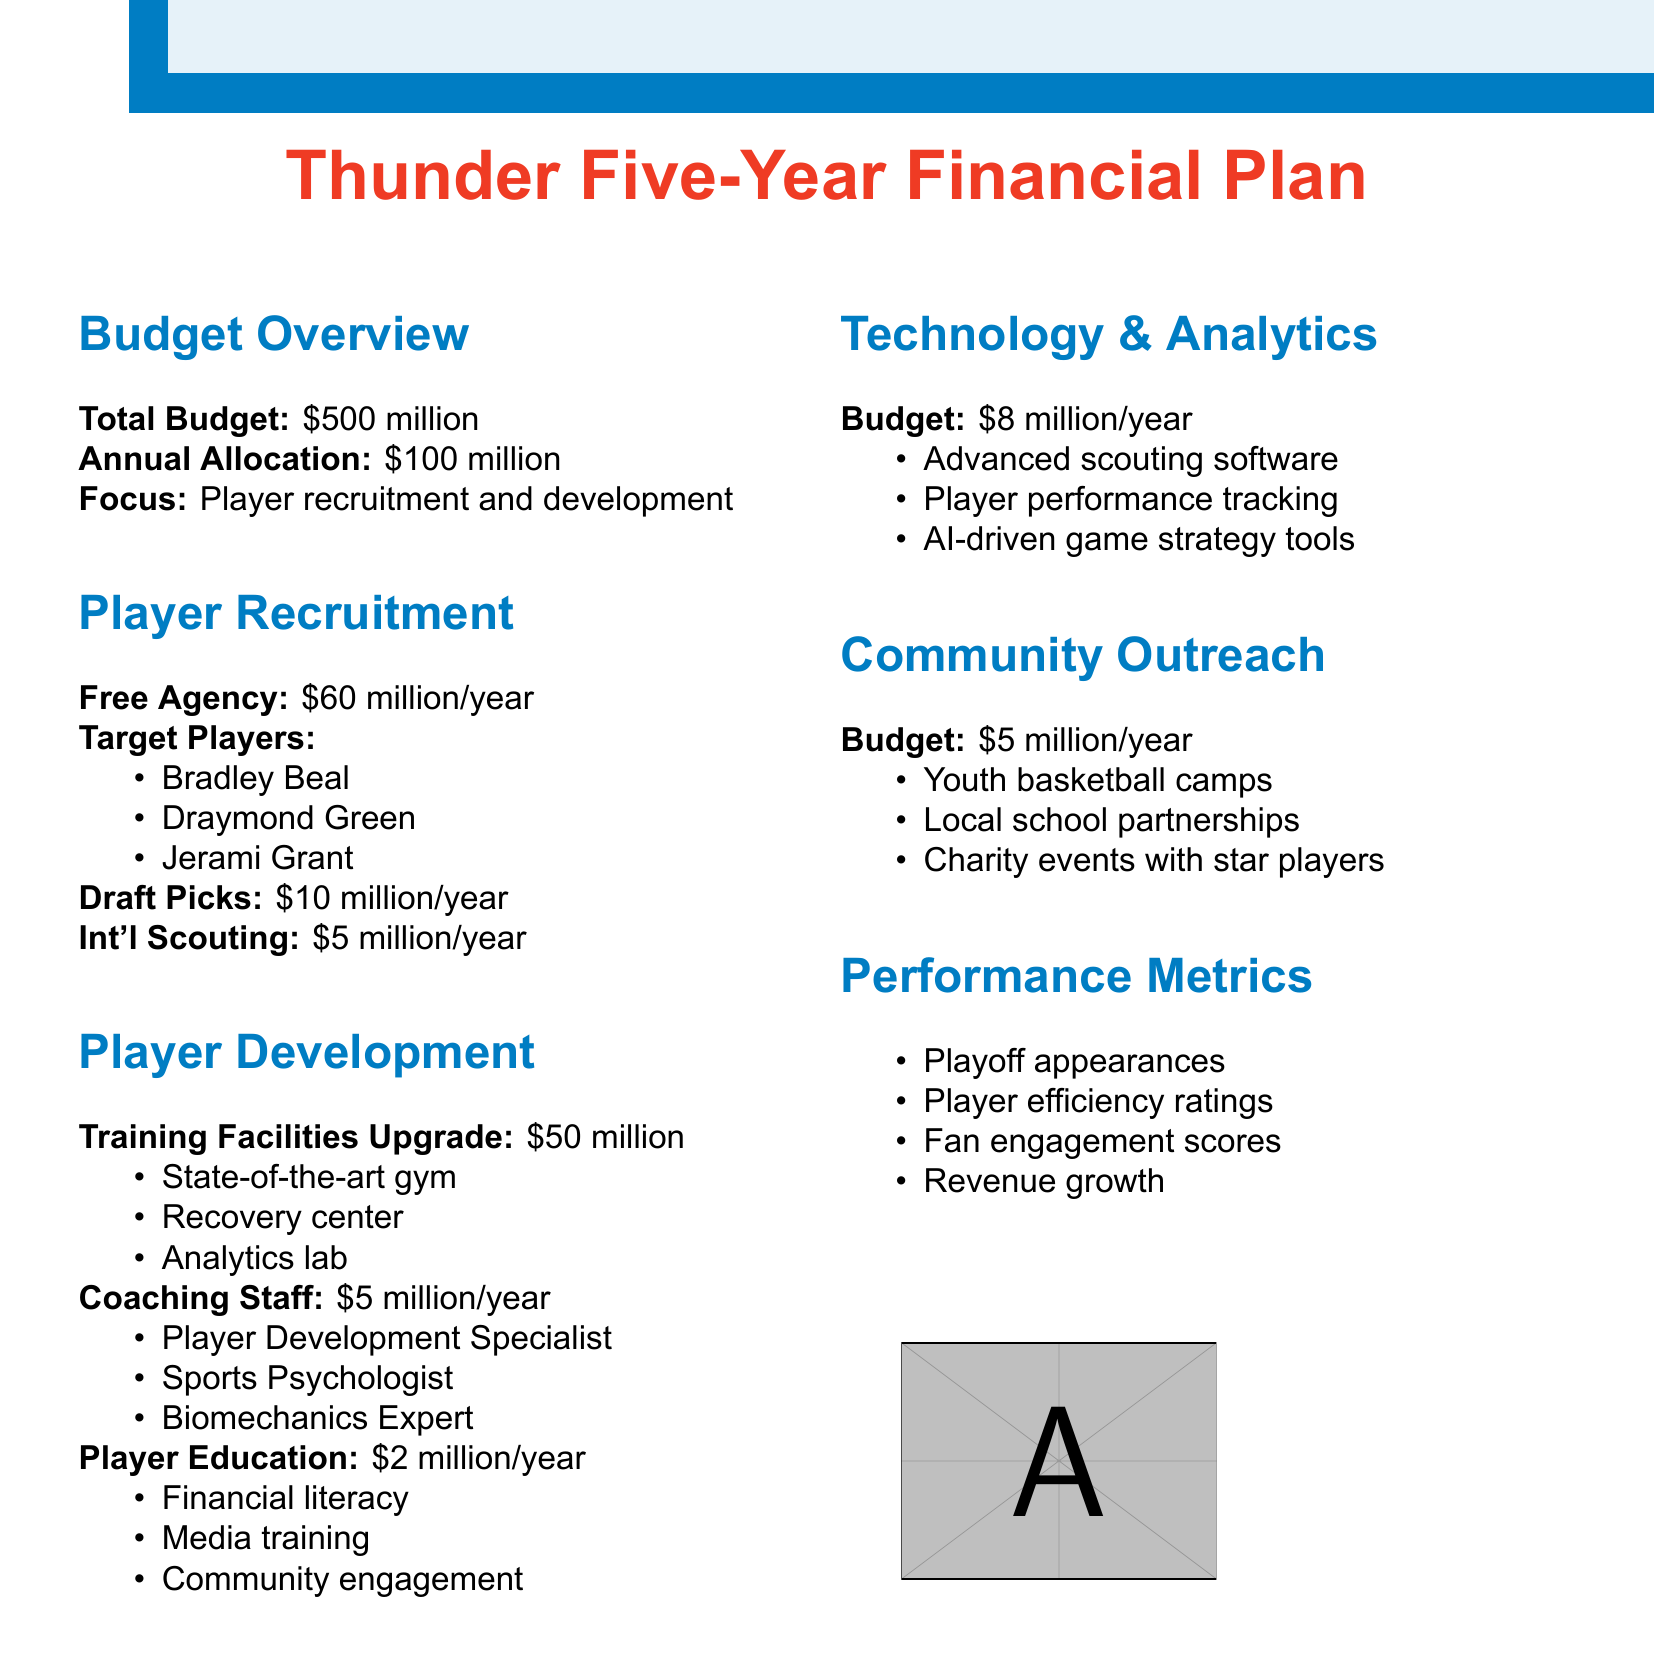What is the total budget for the five-year plan? The total budget is stated clearly in the document as $500 million.
Answer: $500 million How much is allocated annually for player recruitment and development? The document specifies that the annual allocation is $100 million.
Answer: $100 million What is the annual budget for free agency? The budget allocated for free agency each year is listed as $60 million.
Answer: $60 million Who are the three target players for recruitment? The document lists Bradley Beal, Draymond Green, and Jerami Grant as target players.
Answer: Bradley Beal, Draymond Green, Jerami Grant What is the budget for technology and analytics each year? The budget for technology and analytics is mentioned as $8 million per year.
Answer: $8 million How much will be spent on upgrading training facilities? The document indicates that the budget for training facilities upgrade is $50 million.
Answer: $50 million What are the coaching staff costs each year? The document states that the annual cost for the coaching staff is $5 million.
Answer: $5 million What metrics will be used to measure performance? The document lists playoff appearances, player efficiency ratings, fan engagement scores, and revenue growth as performance metrics.
Answer: Playoff appearances, player efficiency ratings, fan engagement scores, revenue growth What is the annual budget for community outreach? The annual allocation for community outreach is specified as $5 million.
Answer: $5 million 